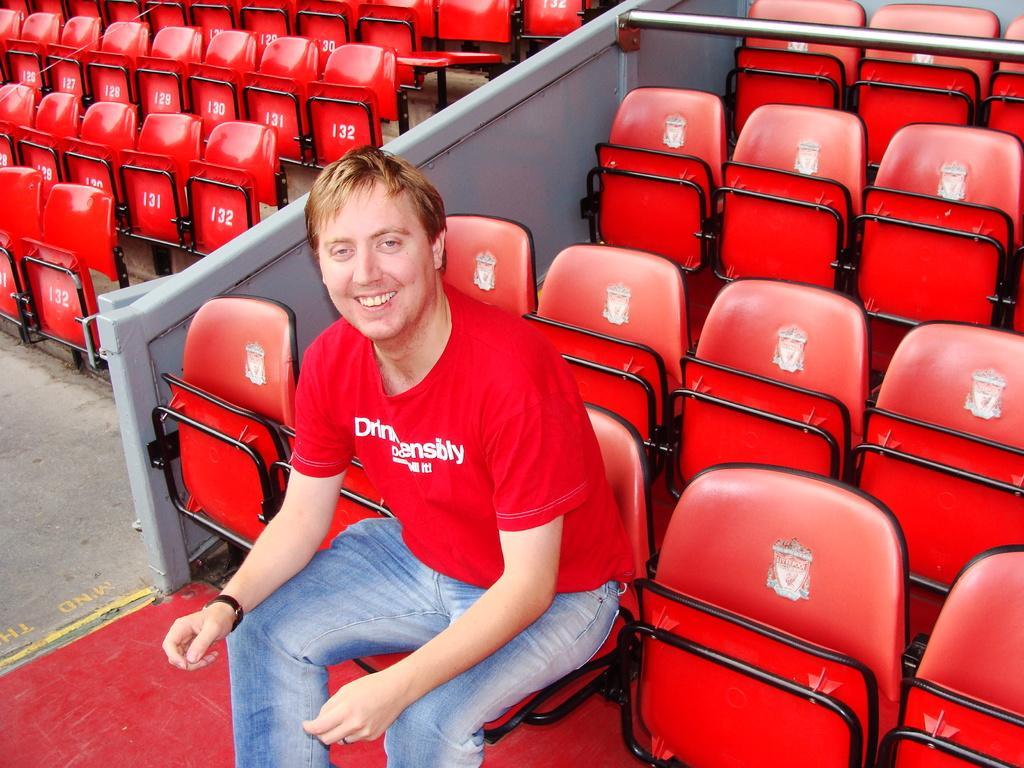In one or two sentences, can you explain what this image depicts? In this image there is a person wearing a red shirt is sitting on the chair. Behind him there are few chairs, in between there is a wall. 